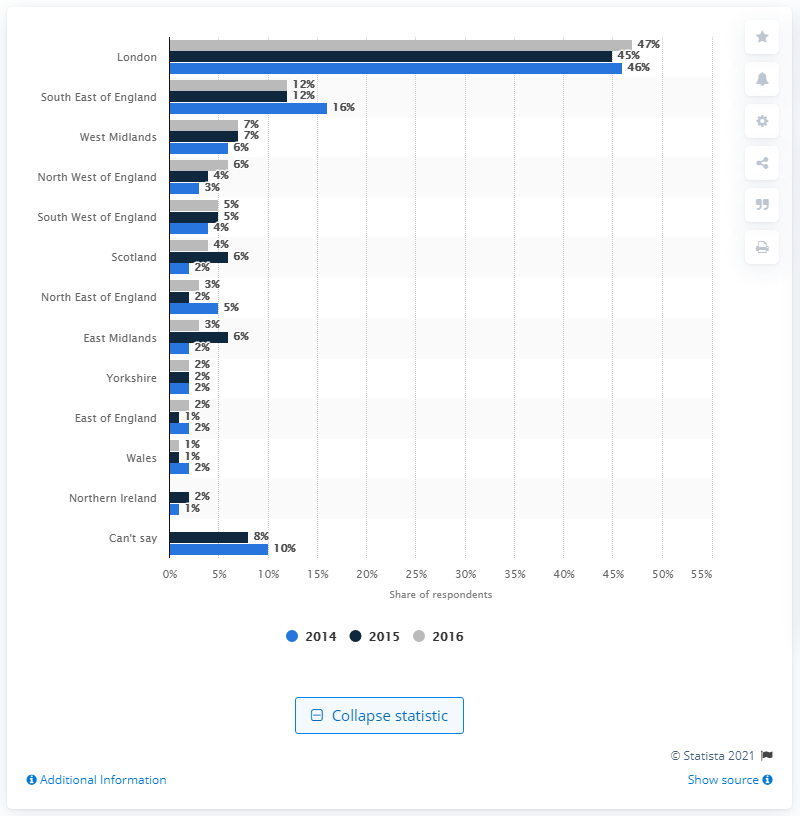Point out several critical features in this image. In 2016, 12% of respondents considered the South East of England to be the most attractive region for Foreign Direct Investment (FDI). 